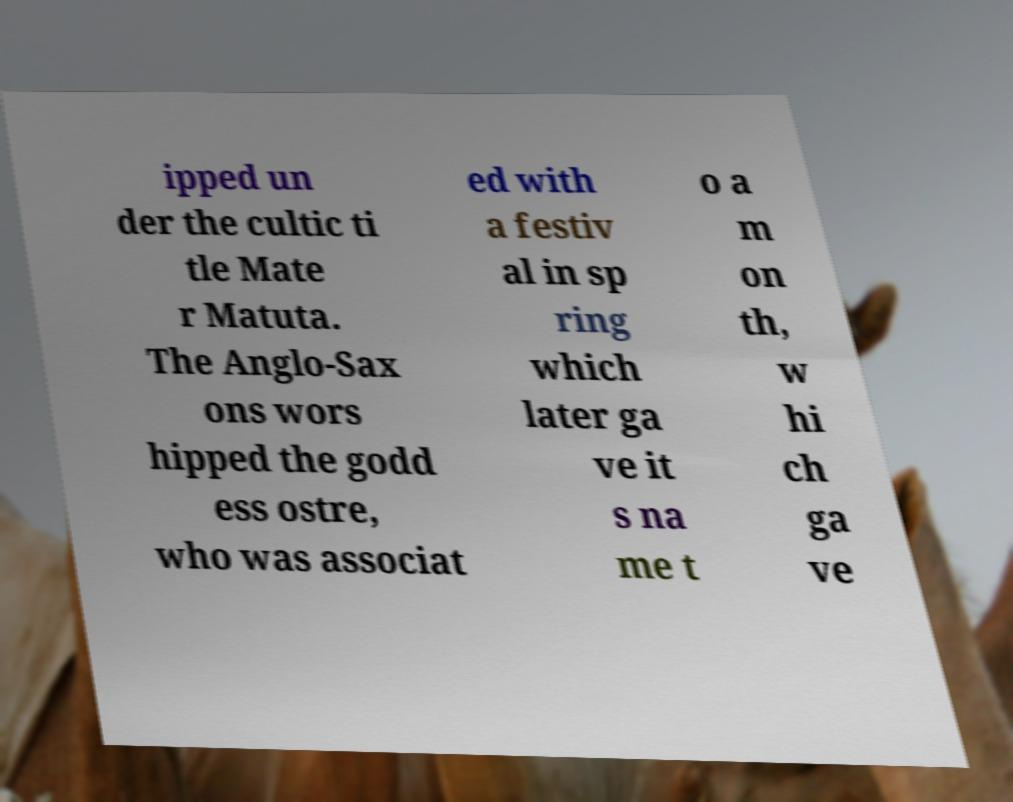Please identify and transcribe the text found in this image. ipped un der the cultic ti tle Mate r Matuta. The Anglo-Sax ons wors hipped the godd ess ostre, who was associat ed with a festiv al in sp ring which later ga ve it s na me t o a m on th, w hi ch ga ve 